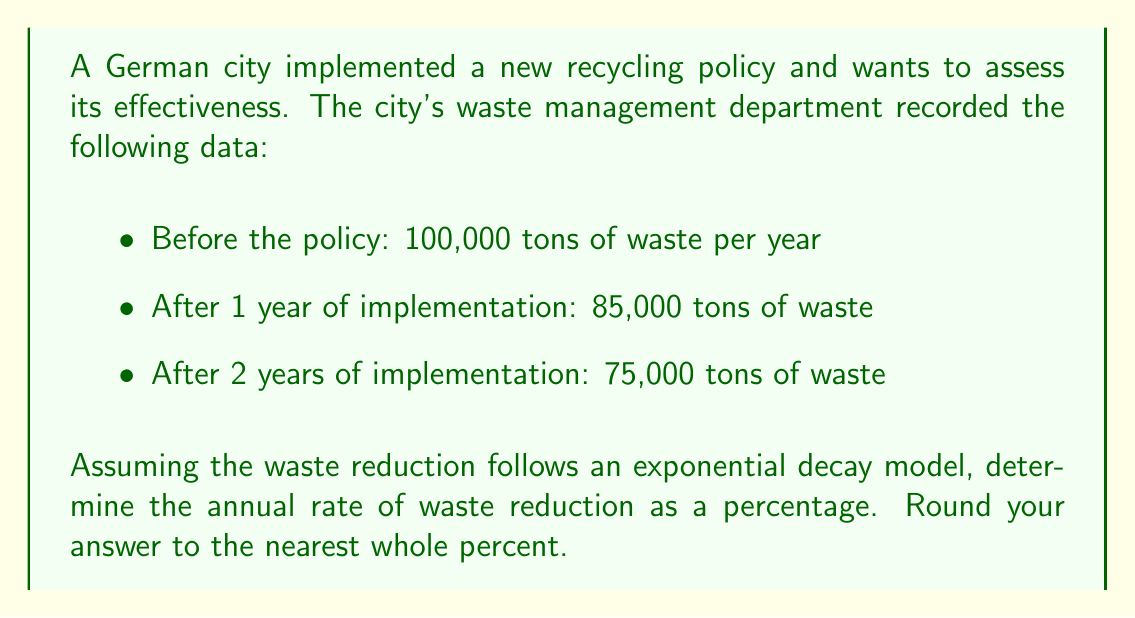Can you answer this question? To solve this problem, we'll use the exponential decay model:

$$ A(t) = A_0 \cdot e^{-rt} $$

Where:
$A(t)$ is the amount at time $t$
$A_0$ is the initial amount
$r$ is the decay rate
$t$ is the time

Step 1: We have two data points to use (initial and after 2 years):
$A_0 = 100,000$ tons
$A(2) = 75,000$ tons

Step 2: Plug these values into the exponential decay formula:
$$ 75,000 = 100,000 \cdot e^{-2r} $$

Step 3: Solve for $r$:
$$ \frac{75,000}{100,000} = e^{-2r} $$
$$ 0.75 = e^{-2r} $$
$$ \ln(0.75) = -2r $$
$$ r = -\frac{\ln(0.75)}{2} $$

Step 4: Calculate $r$:
$$ r = -\frac{\ln(0.75)}{2} \approx 0.1438 $$

Step 5: Convert to a percentage and round to the nearest whole percent:
$$ 0.1438 \times 100\% \approx 14\% $$

Therefore, the annual rate of waste reduction is approximately 14%.
Answer: 14% 